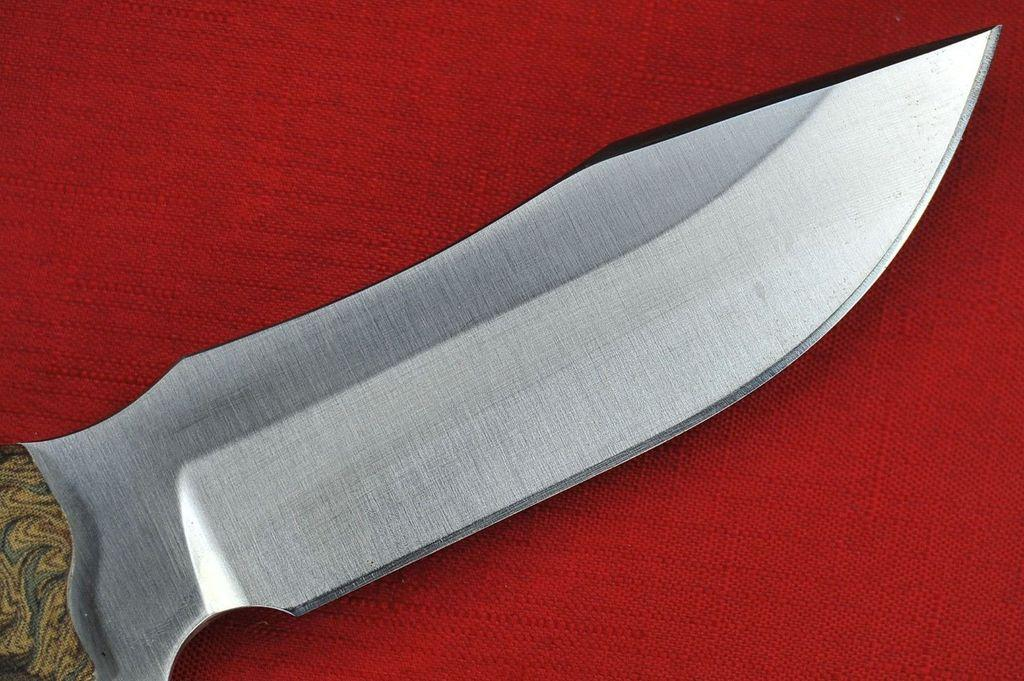What object is present in the image that is typically used for cutting? There is a knife in the image. What is the color of the surface on which the knife is placed? The knife is on a red color surface. What type of maid is visible in the image? There is no maid present in the image. What type of shade is covering the knife in the image? There is no shade covering the knife in the image. 